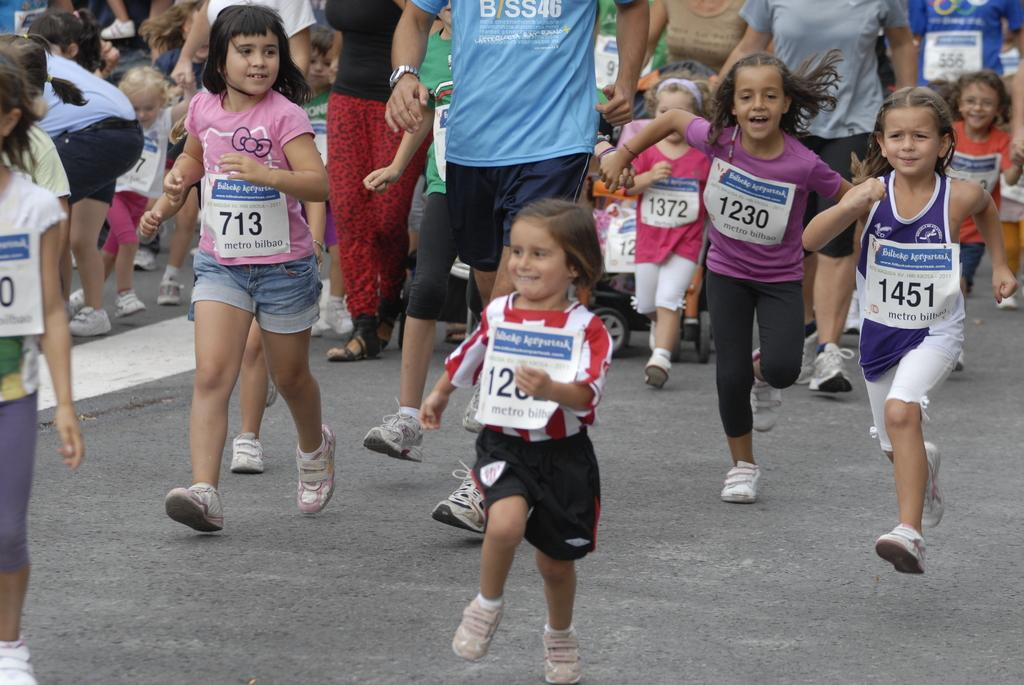Provide a one-sentence caption for the provided image. A group of children are running a marathon with signs that have numbers including 1451. 